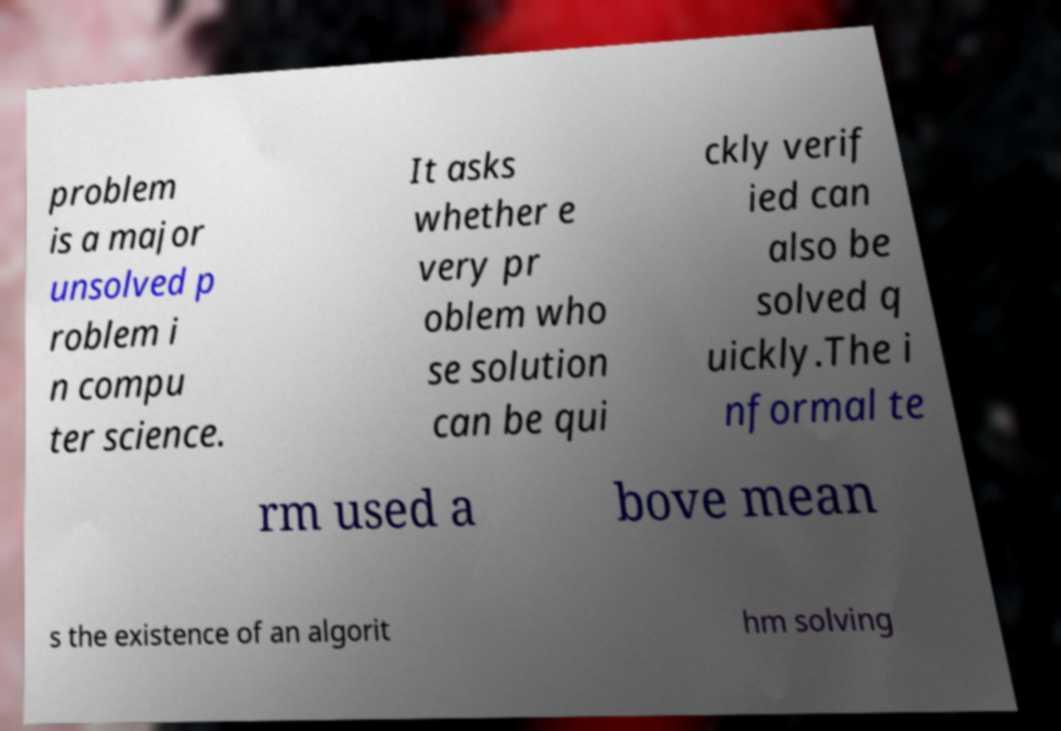Can you read and provide the text displayed in the image?This photo seems to have some interesting text. Can you extract and type it out for me? problem is a major unsolved p roblem i n compu ter science. It asks whether e very pr oblem who se solution can be qui ckly verif ied can also be solved q uickly.The i nformal te rm used a bove mean s the existence of an algorit hm solving 